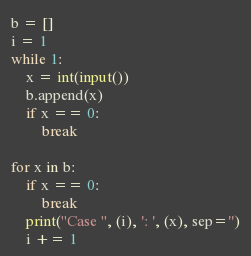Convert code to text. <code><loc_0><loc_0><loc_500><loc_500><_Python_>b = []
i = 1
while 1:
    x = int(input())
    b.append(x)
    if x == 0:
        break

for x in b:
    if x == 0:
        break
    print("Case ", (i), ': ', (x), sep='')
    i += 1</code> 